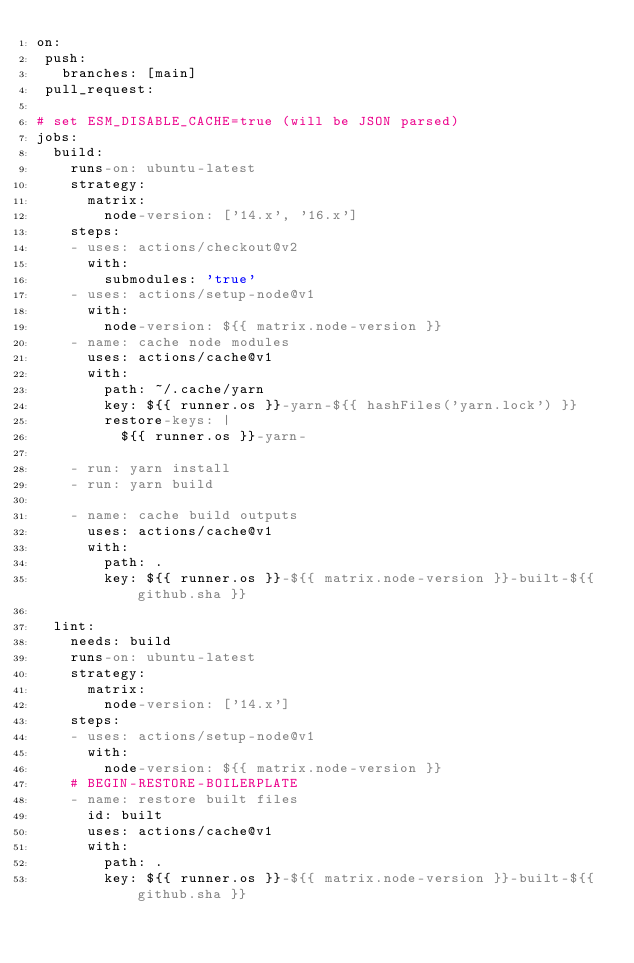<code> <loc_0><loc_0><loc_500><loc_500><_YAML_>on:
 push:
   branches: [main]
 pull_request:

# set ESM_DISABLE_CACHE=true (will be JSON parsed)
jobs:
  build:
    runs-on: ubuntu-latest
    strategy:
      matrix:
        node-version: ['14.x', '16.x']
    steps:
    - uses: actions/checkout@v2
      with:
        submodules: 'true'
    - uses: actions/setup-node@v1
      with:
        node-version: ${{ matrix.node-version }}
    - name: cache node modules
      uses: actions/cache@v1
      with:
        path: ~/.cache/yarn
        key: ${{ runner.os }}-yarn-${{ hashFiles('yarn.lock') }}
        restore-keys: |
          ${{ runner.os }}-yarn-

    - run: yarn install
    - run: yarn build

    - name: cache build outputs
      uses: actions/cache@v1
      with:
        path: .
        key: ${{ runner.os }}-${{ matrix.node-version }}-built-${{ github.sha }}

  lint:
    needs: build
    runs-on: ubuntu-latest
    strategy:
      matrix:
        node-version: ['14.x']
    steps:
    - uses: actions/setup-node@v1
      with:
        node-version: ${{ matrix.node-version }}
    # BEGIN-RESTORE-BOILERPLATE
    - name: restore built files
      id: built
      uses: actions/cache@v1
      with:
        path: .
        key: ${{ runner.os }}-${{ matrix.node-version }}-built-${{ github.sha }}</code> 